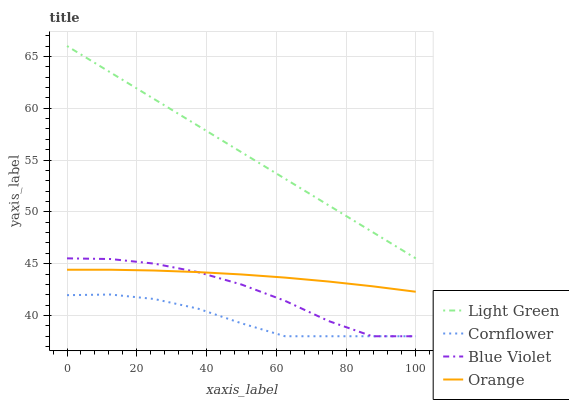Does Cornflower have the minimum area under the curve?
Answer yes or no. Yes. Does Light Green have the maximum area under the curve?
Answer yes or no. Yes. Does Blue Violet have the minimum area under the curve?
Answer yes or no. No. Does Blue Violet have the maximum area under the curve?
Answer yes or no. No. Is Light Green the smoothest?
Answer yes or no. Yes. Is Blue Violet the roughest?
Answer yes or no. Yes. Is Cornflower the smoothest?
Answer yes or no. No. Is Cornflower the roughest?
Answer yes or no. No. Does Cornflower have the lowest value?
Answer yes or no. Yes. Does Light Green have the lowest value?
Answer yes or no. No. Does Light Green have the highest value?
Answer yes or no. Yes. Does Blue Violet have the highest value?
Answer yes or no. No. Is Cornflower less than Orange?
Answer yes or no. Yes. Is Orange greater than Cornflower?
Answer yes or no. Yes. Does Cornflower intersect Blue Violet?
Answer yes or no. Yes. Is Cornflower less than Blue Violet?
Answer yes or no. No. Is Cornflower greater than Blue Violet?
Answer yes or no. No. Does Cornflower intersect Orange?
Answer yes or no. No. 